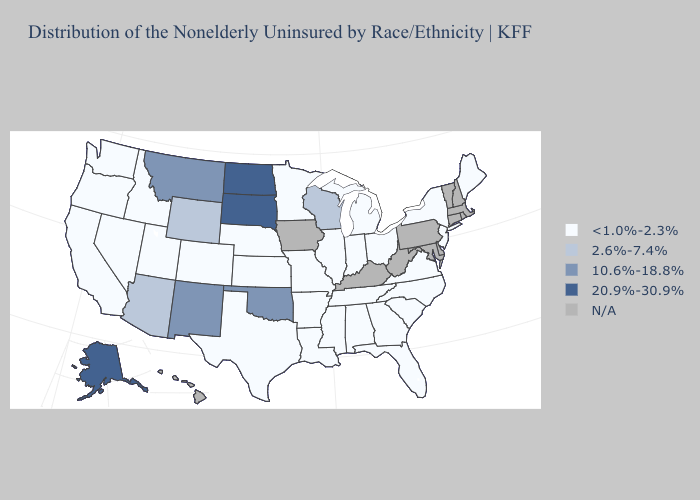What is the value of Rhode Island?
Short answer required. N/A. What is the lowest value in states that border South Carolina?
Write a very short answer. <1.0%-2.3%. What is the highest value in the Northeast ?
Keep it brief. <1.0%-2.3%. What is the value of Texas?
Give a very brief answer. <1.0%-2.3%. What is the highest value in the South ?
Keep it brief. 10.6%-18.8%. Does Oklahoma have the lowest value in the USA?
Write a very short answer. No. Name the states that have a value in the range N/A?
Be succinct. Connecticut, Delaware, Hawaii, Iowa, Kentucky, Maryland, Massachusetts, New Hampshire, Pennsylvania, Rhode Island, Vermont, West Virginia. Does California have the lowest value in the USA?
Quick response, please. Yes. Name the states that have a value in the range 2.6%-7.4%?
Keep it brief. Arizona, Wisconsin, Wyoming. Name the states that have a value in the range N/A?
Give a very brief answer. Connecticut, Delaware, Hawaii, Iowa, Kentucky, Maryland, Massachusetts, New Hampshire, Pennsylvania, Rhode Island, Vermont, West Virginia. Name the states that have a value in the range 2.6%-7.4%?
Concise answer only. Arizona, Wisconsin, Wyoming. Does Texas have the lowest value in the South?
Be succinct. Yes. Among the states that border South Dakota , which have the highest value?
Be succinct. North Dakota. What is the value of Missouri?
Quick response, please. <1.0%-2.3%. 